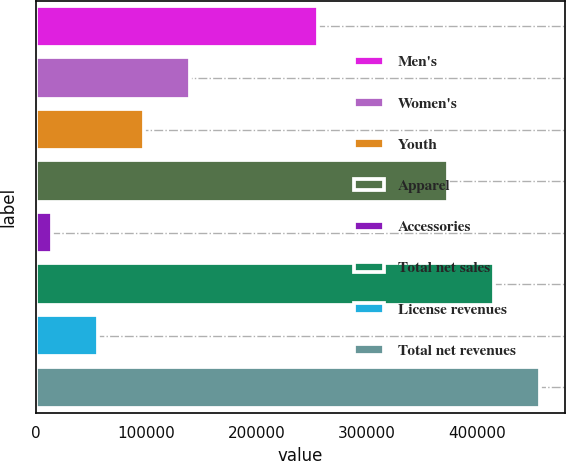Convert chart to OTSL. <chart><loc_0><loc_0><loc_500><loc_500><bar_chart><fcel>Men's<fcel>Women's<fcel>Youth<fcel>Apparel<fcel>Accessories<fcel>Total net sales<fcel>License revenues<fcel>Total net revenues<nl><fcel>255681<fcel>139635<fcel>98055.4<fcel>373221<fcel>14897<fcel>414992<fcel>56476.2<fcel>456571<nl></chart> 